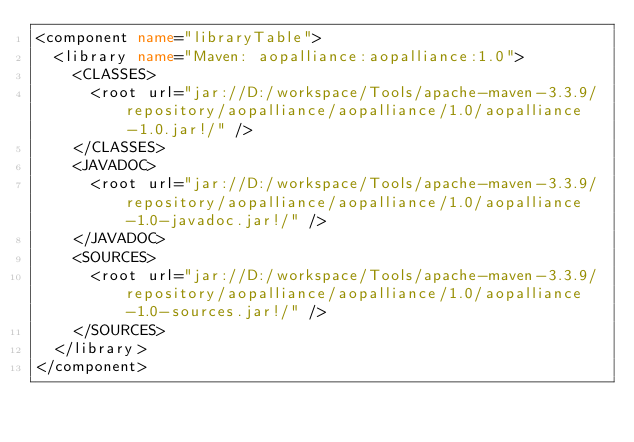<code> <loc_0><loc_0><loc_500><loc_500><_XML_><component name="libraryTable">
  <library name="Maven: aopalliance:aopalliance:1.0">
    <CLASSES>
      <root url="jar://D:/workspace/Tools/apache-maven-3.3.9/repository/aopalliance/aopalliance/1.0/aopalliance-1.0.jar!/" />
    </CLASSES>
    <JAVADOC>
      <root url="jar://D:/workspace/Tools/apache-maven-3.3.9/repository/aopalliance/aopalliance/1.0/aopalliance-1.0-javadoc.jar!/" />
    </JAVADOC>
    <SOURCES>
      <root url="jar://D:/workspace/Tools/apache-maven-3.3.9/repository/aopalliance/aopalliance/1.0/aopalliance-1.0-sources.jar!/" />
    </SOURCES>
  </library>
</component></code> 